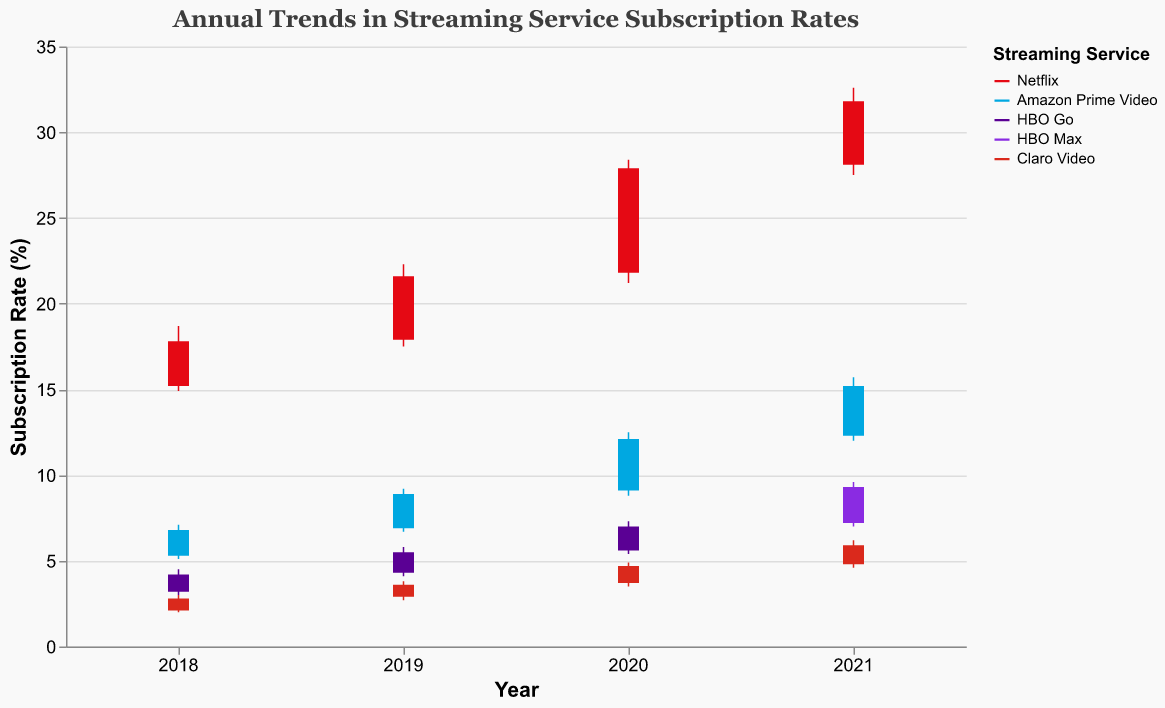What is the title of the figure? The title is displayed at the top of the figure and indicates what the figure is about. It helps to understand the main purpose of the chart.
Answer: Annual Trends in Streaming Service Subscription Rates What is the subscription rate range for Netflix in 2020? To answer this, look at the high and low subscription rates for Netflix in the year 2020 shown in the figure.
Answer: 21.2% to 28.4% How did Netflix’s subscription rate change from the beginning to the end of 2019? To determine the change, subtract the open rate of 2019 from the close rate of the same year for Netflix.
Answer: It increased by 3.7% Which streaming service had the highest subscription rate in 2021? Compare the high rates for all streaming services in the year 2021 to find the highest value.
Answer: Netflix What are the color codes used to represent HBO services? These colors distinguish HBO Go and HBO Max from other services and help identify subscriptions related to HBO. Look at the legend for the specific colors.
Answer: Purple and Dark Violet What is the average high subscription rate for Claro Video over the years? Add the high subscription rates for Claro Video across all years and divide by the number of years (4). The years and values are: 3.0 (2018), 3.8 (2019), 4.9 (2020), 6.2 (2021). (3.0 + 3.8 + 4.9 + 6.2) / 4 = 17.9 / 4 = 4.475
Answer: 4.475% How did HBO Go’s subscription rate change from 2018 to 2020? Calculate the difference between the close rate of 2020 and the close rate of 2018 for HBO Go.
Answer: Increased by 2.8% Which streaming service had the lowest subscription rate in 2018? Compare the low rates for all services in 2018 and identify the one with the lowest value.
Answer: Claro Video Between Netflix and Amazon Prime Video, which showed a greater increase in subscription rate from 2018 to 2021? Calculate the increase for both from their 2018 to 2021 close rates. Netflix: 31.8 - 17.8 = 14. Amazon Prime Video: 15.2 - 6.8 = 8.4. Compare the two results.
Answer: Netflix What was the largest yearly increase in subscription rates for any service? Compare the increase from the open to the close rates within the same year across all services and years to find the maximum yearly increase.
Answer: Netflix in 2020 with an increase of 6.1% 